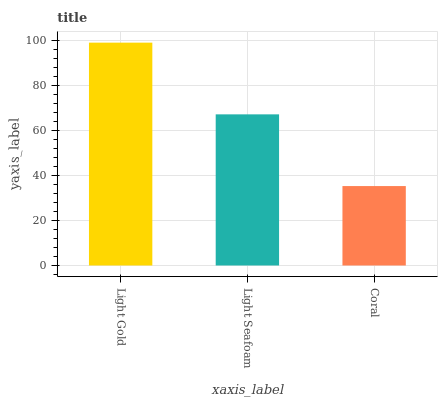Is Coral the minimum?
Answer yes or no. Yes. Is Light Gold the maximum?
Answer yes or no. Yes. Is Light Seafoam the minimum?
Answer yes or no. No. Is Light Seafoam the maximum?
Answer yes or no. No. Is Light Gold greater than Light Seafoam?
Answer yes or no. Yes. Is Light Seafoam less than Light Gold?
Answer yes or no. Yes. Is Light Seafoam greater than Light Gold?
Answer yes or no. No. Is Light Gold less than Light Seafoam?
Answer yes or no. No. Is Light Seafoam the high median?
Answer yes or no. Yes. Is Light Seafoam the low median?
Answer yes or no. Yes. Is Light Gold the high median?
Answer yes or no. No. Is Coral the low median?
Answer yes or no. No. 